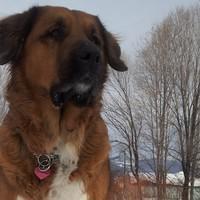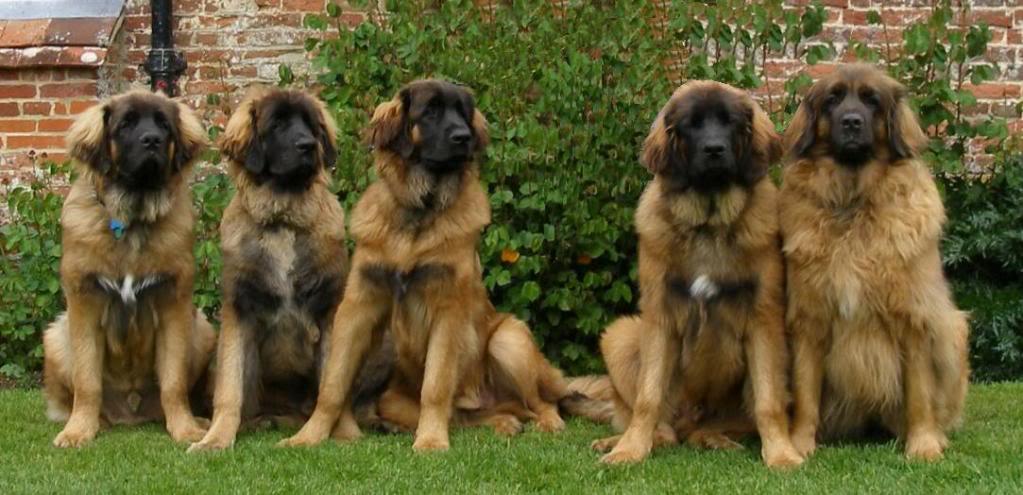The first image is the image on the left, the second image is the image on the right. Analyze the images presented: Is the assertion "One image shows at least five similar looking dogs posed sitting upright on grass in front of a house, with no humans present." valid? Answer yes or no. Yes. The first image is the image on the left, the second image is the image on the right. Evaluate the accuracy of this statement regarding the images: "There are no more than two dogs in the right image.". Is it true? Answer yes or no. No. 